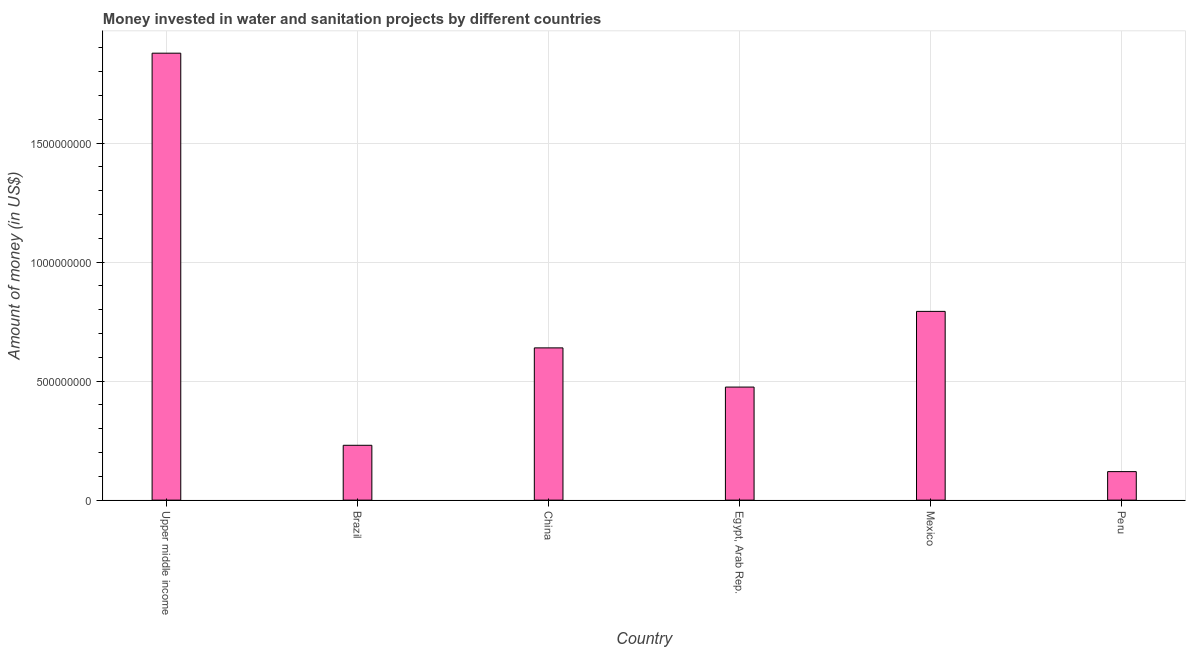Does the graph contain any zero values?
Ensure brevity in your answer.  No. Does the graph contain grids?
Ensure brevity in your answer.  Yes. What is the title of the graph?
Your answer should be very brief. Money invested in water and sanitation projects by different countries. What is the label or title of the Y-axis?
Provide a succinct answer. Amount of money (in US$). What is the investment in Mexico?
Make the answer very short. 7.93e+08. Across all countries, what is the maximum investment?
Offer a terse response. 1.88e+09. Across all countries, what is the minimum investment?
Offer a very short reply. 1.20e+08. In which country was the investment maximum?
Keep it short and to the point. Upper middle income. What is the sum of the investment?
Your answer should be very brief. 4.14e+09. What is the difference between the investment in China and Upper middle income?
Your answer should be very brief. -1.24e+09. What is the average investment per country?
Offer a very short reply. 6.89e+08. What is the median investment?
Give a very brief answer. 5.57e+08. In how many countries, is the investment greater than 300000000 US$?
Ensure brevity in your answer.  4. What is the ratio of the investment in Egypt, Arab Rep. to that in Peru?
Offer a very short reply. 3.96. Is the investment in Brazil less than that in Upper middle income?
Your response must be concise. Yes. What is the difference between the highest and the second highest investment?
Offer a terse response. 1.08e+09. What is the difference between the highest and the lowest investment?
Offer a terse response. 1.76e+09. In how many countries, is the investment greater than the average investment taken over all countries?
Keep it short and to the point. 2. Are all the bars in the graph horizontal?
Your response must be concise. No. How many countries are there in the graph?
Offer a terse response. 6. What is the difference between two consecutive major ticks on the Y-axis?
Give a very brief answer. 5.00e+08. What is the Amount of money (in US$) of Upper middle income?
Offer a very short reply. 1.88e+09. What is the Amount of money (in US$) in Brazil?
Your answer should be compact. 2.30e+08. What is the Amount of money (in US$) of China?
Keep it short and to the point. 6.40e+08. What is the Amount of money (in US$) in Egypt, Arab Rep.?
Provide a succinct answer. 4.75e+08. What is the Amount of money (in US$) in Mexico?
Offer a very short reply. 7.93e+08. What is the Amount of money (in US$) of Peru?
Make the answer very short. 1.20e+08. What is the difference between the Amount of money (in US$) in Upper middle income and Brazil?
Offer a very short reply. 1.65e+09. What is the difference between the Amount of money (in US$) in Upper middle income and China?
Your answer should be compact. 1.24e+09. What is the difference between the Amount of money (in US$) in Upper middle income and Egypt, Arab Rep.?
Provide a succinct answer. 1.40e+09. What is the difference between the Amount of money (in US$) in Upper middle income and Mexico?
Offer a very short reply. 1.08e+09. What is the difference between the Amount of money (in US$) in Upper middle income and Peru?
Ensure brevity in your answer.  1.76e+09. What is the difference between the Amount of money (in US$) in Brazil and China?
Offer a terse response. -4.09e+08. What is the difference between the Amount of money (in US$) in Brazil and Egypt, Arab Rep.?
Keep it short and to the point. -2.45e+08. What is the difference between the Amount of money (in US$) in Brazil and Mexico?
Provide a succinct answer. -5.63e+08. What is the difference between the Amount of money (in US$) in Brazil and Peru?
Ensure brevity in your answer.  1.11e+08. What is the difference between the Amount of money (in US$) in China and Egypt, Arab Rep.?
Your answer should be very brief. 1.65e+08. What is the difference between the Amount of money (in US$) in China and Mexico?
Provide a short and direct response. -1.53e+08. What is the difference between the Amount of money (in US$) in China and Peru?
Your answer should be compact. 5.20e+08. What is the difference between the Amount of money (in US$) in Egypt, Arab Rep. and Mexico?
Offer a terse response. -3.18e+08. What is the difference between the Amount of money (in US$) in Egypt, Arab Rep. and Peru?
Ensure brevity in your answer.  3.55e+08. What is the difference between the Amount of money (in US$) in Mexico and Peru?
Your response must be concise. 6.73e+08. What is the ratio of the Amount of money (in US$) in Upper middle income to that in Brazil?
Provide a short and direct response. 8.15. What is the ratio of the Amount of money (in US$) in Upper middle income to that in China?
Your answer should be very brief. 2.94. What is the ratio of the Amount of money (in US$) in Upper middle income to that in Egypt, Arab Rep.?
Your answer should be very brief. 3.95. What is the ratio of the Amount of money (in US$) in Upper middle income to that in Mexico?
Provide a succinct answer. 2.37. What is the ratio of the Amount of money (in US$) in Upper middle income to that in Peru?
Keep it short and to the point. 15.68. What is the ratio of the Amount of money (in US$) in Brazil to that in China?
Your answer should be compact. 0.36. What is the ratio of the Amount of money (in US$) in Brazil to that in Egypt, Arab Rep.?
Your response must be concise. 0.48. What is the ratio of the Amount of money (in US$) in Brazil to that in Mexico?
Give a very brief answer. 0.29. What is the ratio of the Amount of money (in US$) in Brazil to that in Peru?
Give a very brief answer. 1.92. What is the ratio of the Amount of money (in US$) in China to that in Egypt, Arab Rep.?
Ensure brevity in your answer.  1.35. What is the ratio of the Amount of money (in US$) in China to that in Mexico?
Ensure brevity in your answer.  0.81. What is the ratio of the Amount of money (in US$) in China to that in Peru?
Ensure brevity in your answer.  5.34. What is the ratio of the Amount of money (in US$) in Egypt, Arab Rep. to that in Mexico?
Ensure brevity in your answer.  0.6. What is the ratio of the Amount of money (in US$) in Egypt, Arab Rep. to that in Peru?
Your answer should be very brief. 3.96. What is the ratio of the Amount of money (in US$) in Mexico to that in Peru?
Your answer should be compact. 6.62. 